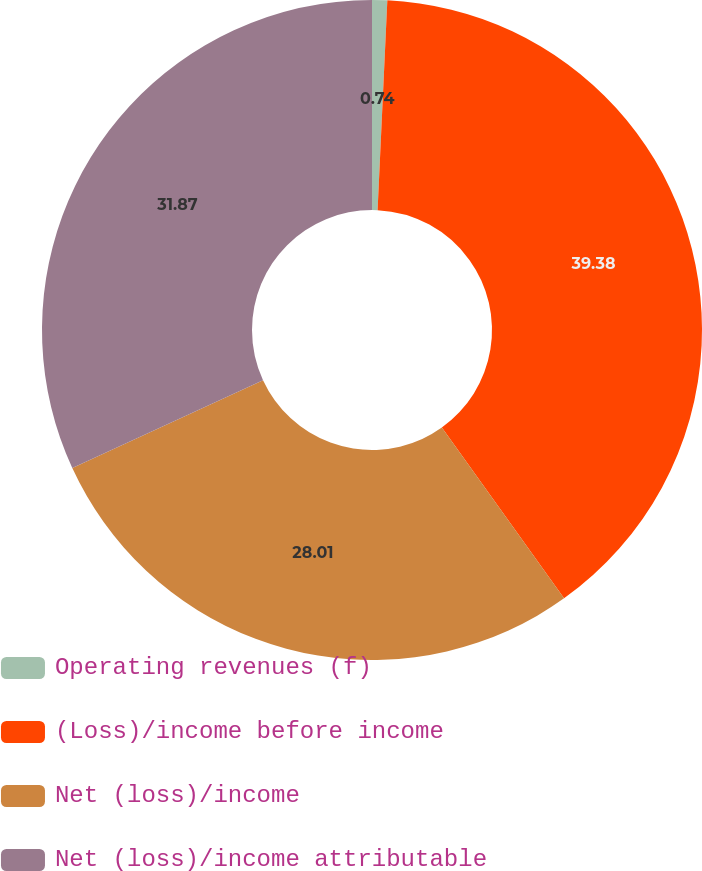Convert chart to OTSL. <chart><loc_0><loc_0><loc_500><loc_500><pie_chart><fcel>Operating revenues (f)<fcel>(Loss)/income before income<fcel>Net (loss)/income<fcel>Net (loss)/income attributable<nl><fcel>0.74%<fcel>39.37%<fcel>28.01%<fcel>31.87%<nl></chart> 